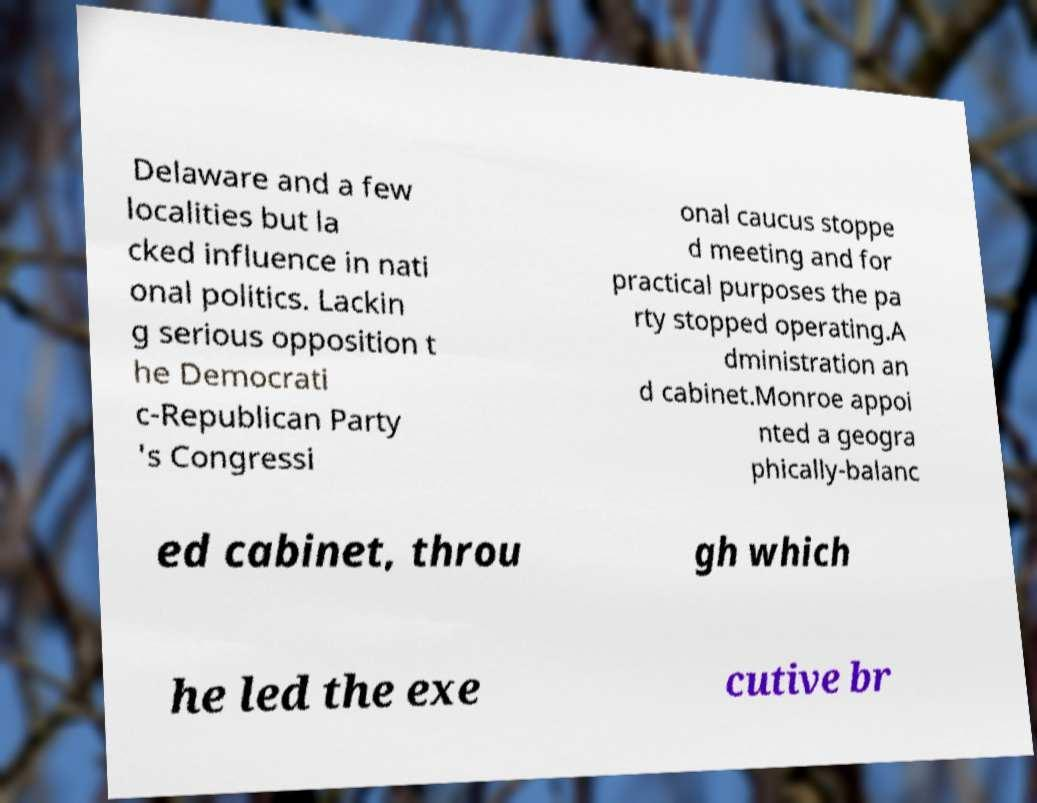Can you read and provide the text displayed in the image?This photo seems to have some interesting text. Can you extract and type it out for me? Delaware and a few localities but la cked influence in nati onal politics. Lackin g serious opposition t he Democrati c-Republican Party 's Congressi onal caucus stoppe d meeting and for practical purposes the pa rty stopped operating.A dministration an d cabinet.Monroe appoi nted a geogra phically-balanc ed cabinet, throu gh which he led the exe cutive br 